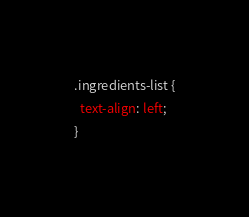Convert code to text. <code><loc_0><loc_0><loc_500><loc_500><_CSS_>.ingredients-list {
  text-align: left;
}</code> 